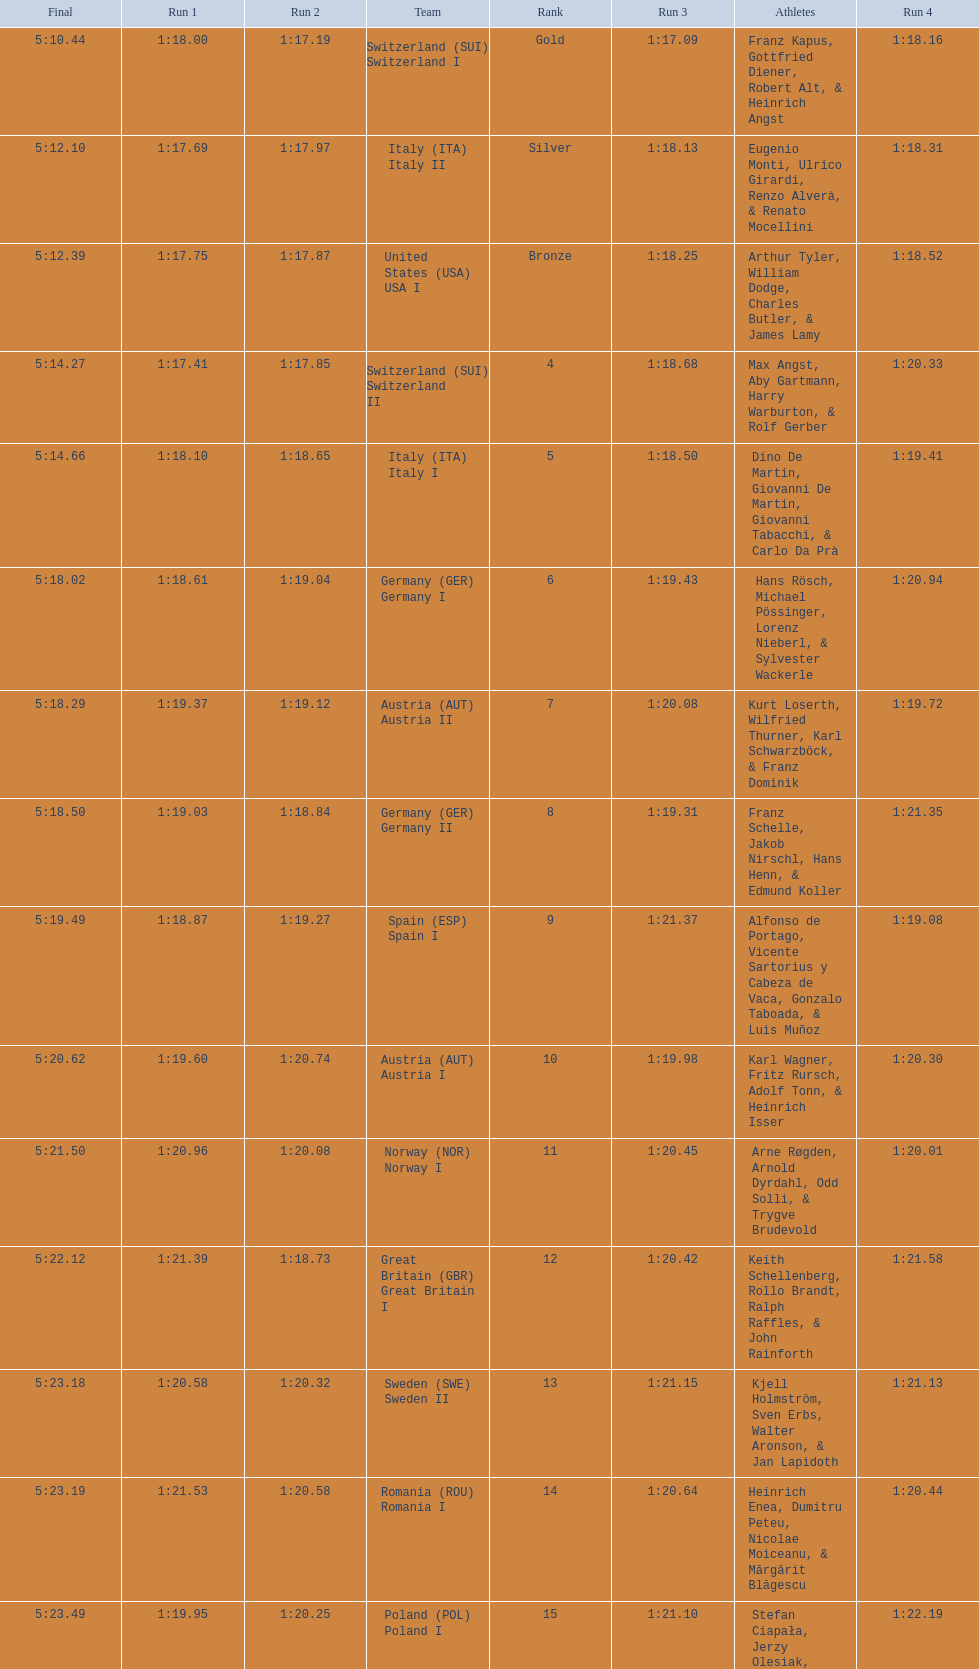Which team won the most runs? Switzerland. 